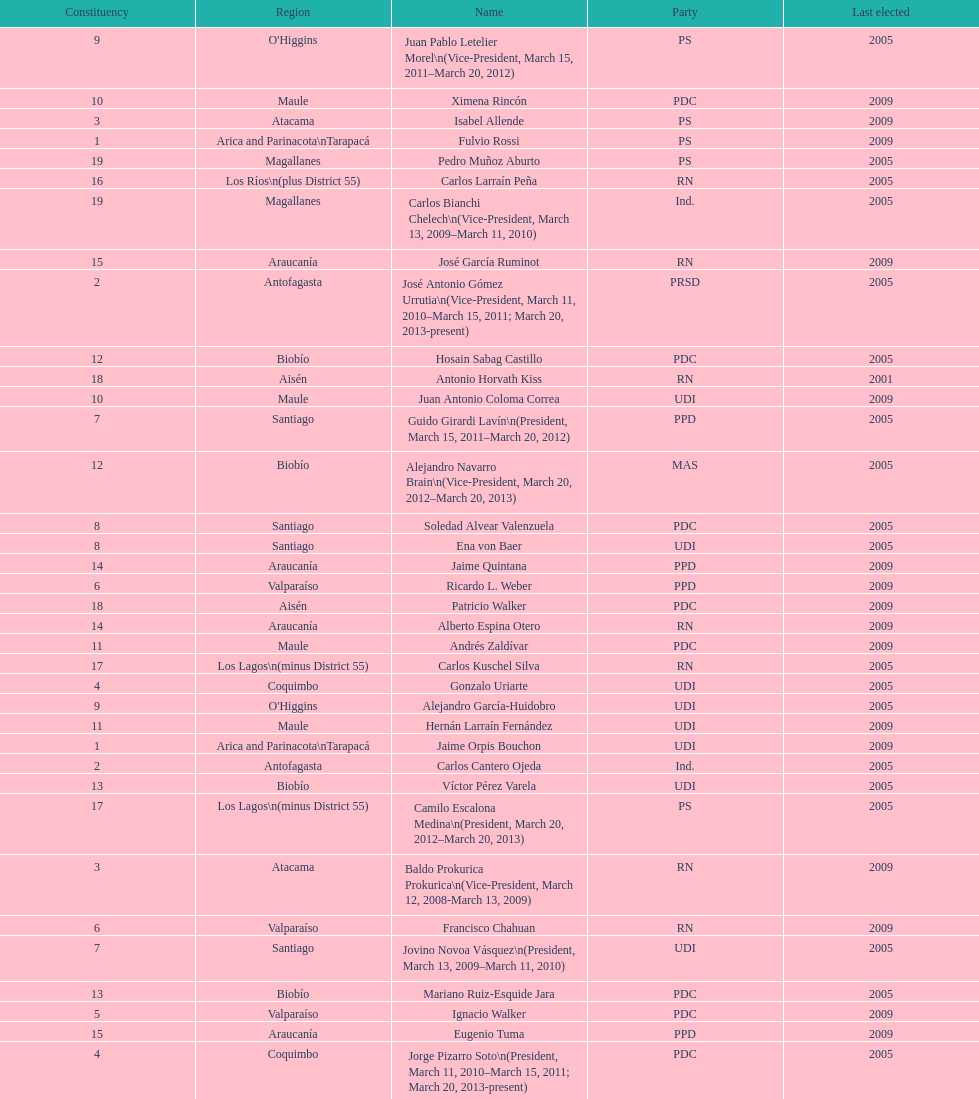Who was not last elected in either 2005 or 2009? Antonio Horvath Kiss. 